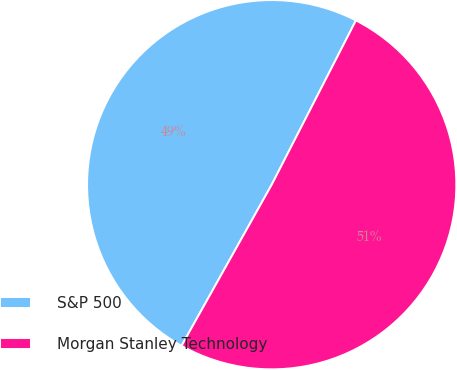<chart> <loc_0><loc_0><loc_500><loc_500><pie_chart><fcel>S&P 500<fcel>Morgan Stanley Technology<nl><fcel>49.42%<fcel>50.58%<nl></chart> 